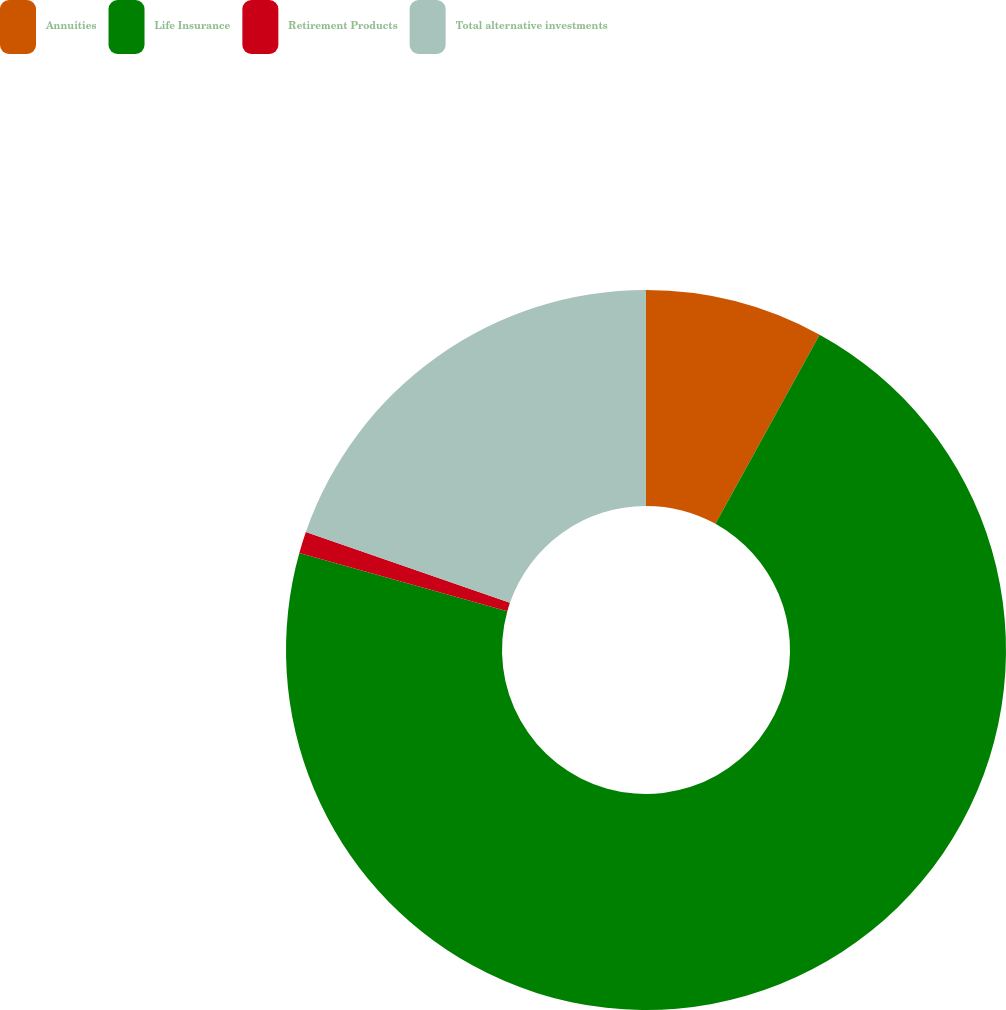<chart> <loc_0><loc_0><loc_500><loc_500><pie_chart><fcel>Annuities<fcel>Life Insurance<fcel>Retirement Products<fcel>Total alternative investments<nl><fcel>8.01%<fcel>71.34%<fcel>0.97%<fcel>19.69%<nl></chart> 